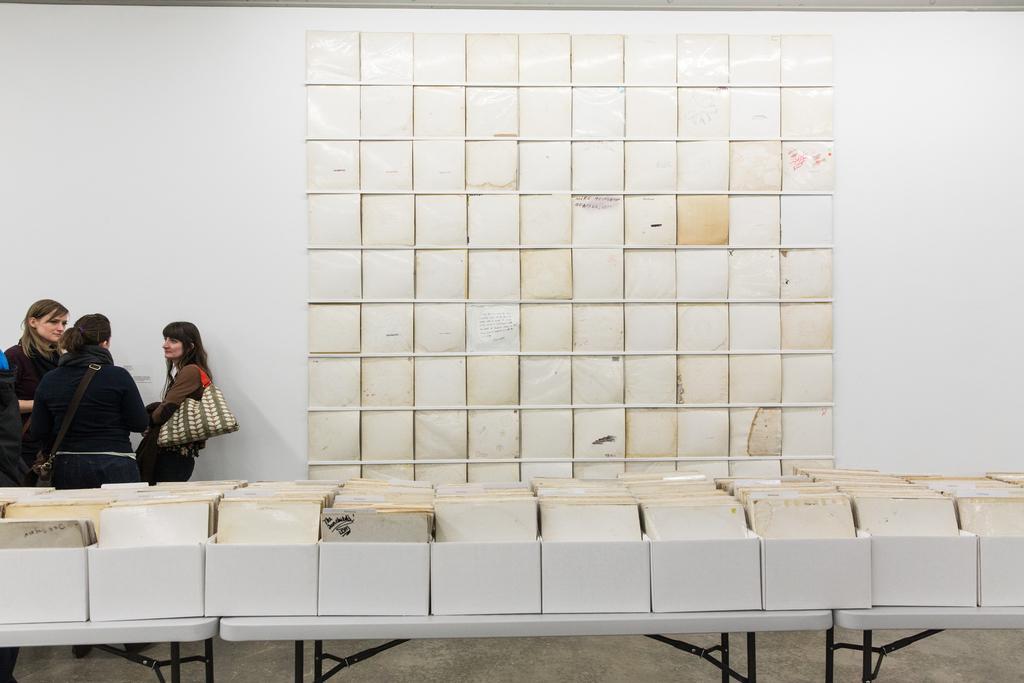Please provide a concise description of this image. In this image on the bottom there are some boxes and some books are there on the table and on the background there is wall and some books are there. And on the left side there are three women who are standing and talking. 